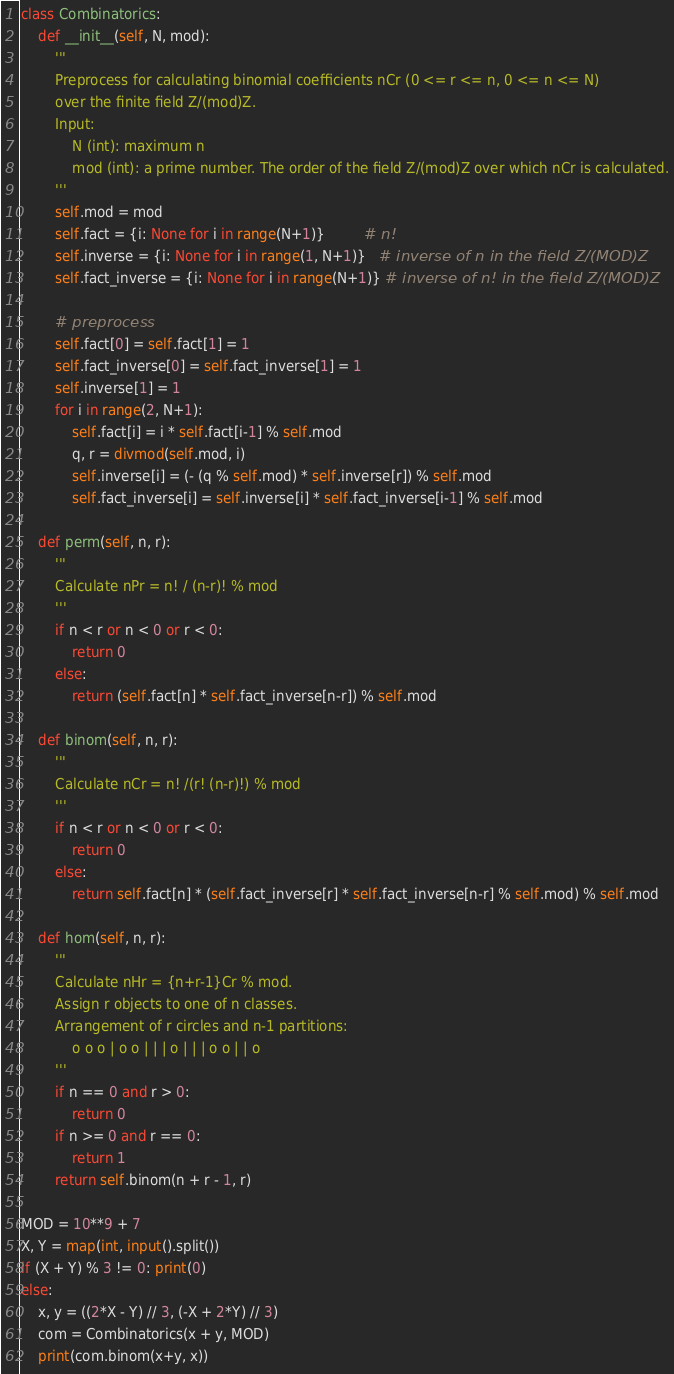Convert code to text. <code><loc_0><loc_0><loc_500><loc_500><_Python_>class Combinatorics:
    def __init__(self, N, mod):
        '''
        Preprocess for calculating binomial coefficients nCr (0 <= r <= n, 0 <= n <= N)
        over the finite field Z/(mod)Z.
        Input:
            N (int): maximum n
            mod (int): a prime number. The order of the field Z/(mod)Z over which nCr is calculated.
        '''
        self.mod = mod
        self.fact = {i: None for i in range(N+1)}         # n!
        self.inverse = {i: None for i in range(1, N+1)}   # inverse of n in the field Z/(MOD)Z
        self.fact_inverse = {i: None for i in range(N+1)} # inverse of n! in the field Z/(MOD)Z
        
        # preprocess
        self.fact[0] = self.fact[1] = 1
        self.fact_inverse[0] = self.fact_inverse[1] = 1
        self.inverse[1] = 1
        for i in range(2, N+1):
            self.fact[i] = i * self.fact[i-1] % self.mod
            q, r = divmod(self.mod, i)
            self.inverse[i] = (- (q % self.mod) * self.inverse[r]) % self.mod
            self.fact_inverse[i] = self.inverse[i] * self.fact_inverse[i-1] % self.mod
    
    def perm(self, n, r):
        '''
        Calculate nPr = n! / (n-r)! % mod
        '''
        if n < r or n < 0 or r < 0:
            return 0
        else:
            return (self.fact[n] * self.fact_inverse[n-r]) % self.mod
    
    def binom(self, n, r):
        '''
        Calculate nCr = n! /(r! (n-r)!) % mod
        '''
        if n < r or n < 0 or r < 0:
            return 0
        else:
            return self.fact[n] * (self.fact_inverse[r] * self.fact_inverse[n-r] % self.mod) % self.mod
        
    def hom(self, n, r):
        '''
        Calculate nHr = {n+r-1}Cr % mod.
        Assign r objects to one of n classes.
        Arrangement of r circles and n-1 partitions:
            o o o | o o | | | o | | | o o | | o
        '''
        if n == 0 and r > 0:
            return 0
        if n >= 0 and r == 0:
            return 1
        return self.binom(n + r - 1, r)

MOD = 10**9 + 7
X, Y = map(int, input().split())
if (X + Y) % 3 != 0: print(0)
else:
    x, y = ((2*X - Y) // 3, (-X + 2*Y) // 3)
    com = Combinatorics(x + y, MOD)
    print(com.binom(x+y, x))
</code> 